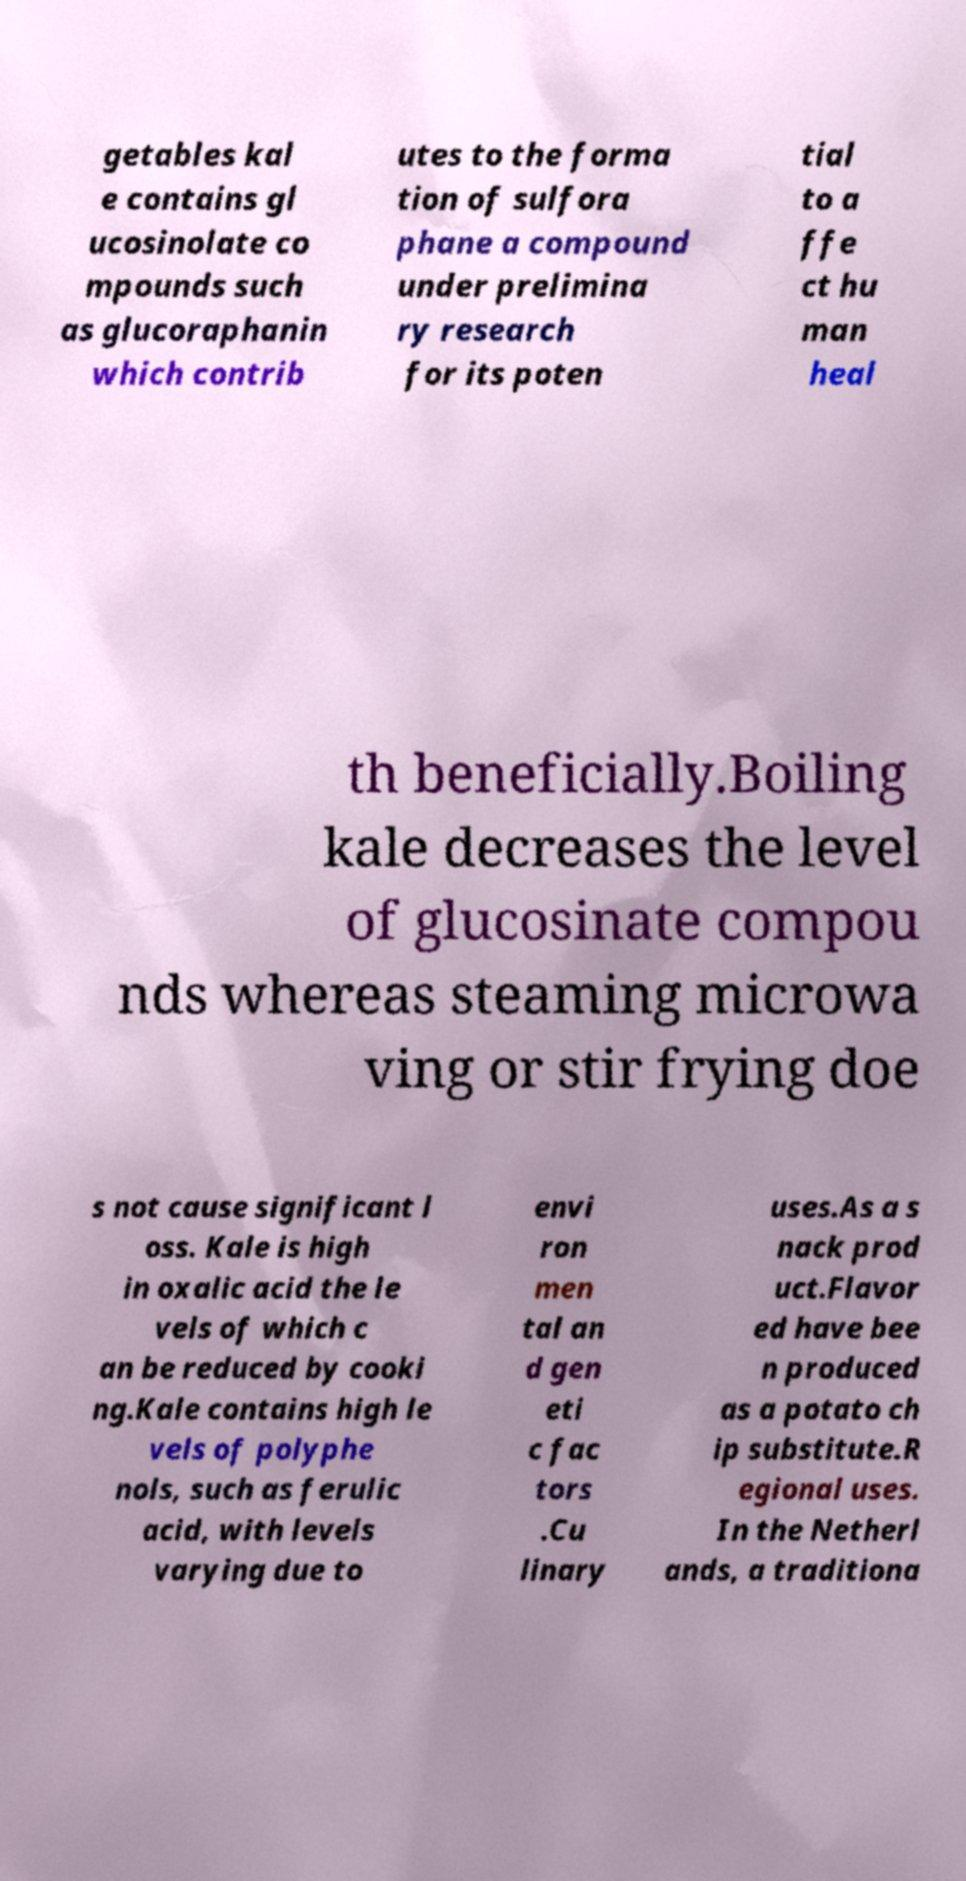I need the written content from this picture converted into text. Can you do that? getables kal e contains gl ucosinolate co mpounds such as glucoraphanin which contrib utes to the forma tion of sulfora phane a compound under prelimina ry research for its poten tial to a ffe ct hu man heal th beneficially.Boiling kale decreases the level of glucosinate compou nds whereas steaming microwa ving or stir frying doe s not cause significant l oss. Kale is high in oxalic acid the le vels of which c an be reduced by cooki ng.Kale contains high le vels of polyphe nols, such as ferulic acid, with levels varying due to envi ron men tal an d gen eti c fac tors .Cu linary uses.As a s nack prod uct.Flavor ed have bee n produced as a potato ch ip substitute.R egional uses. In the Netherl ands, a traditiona 